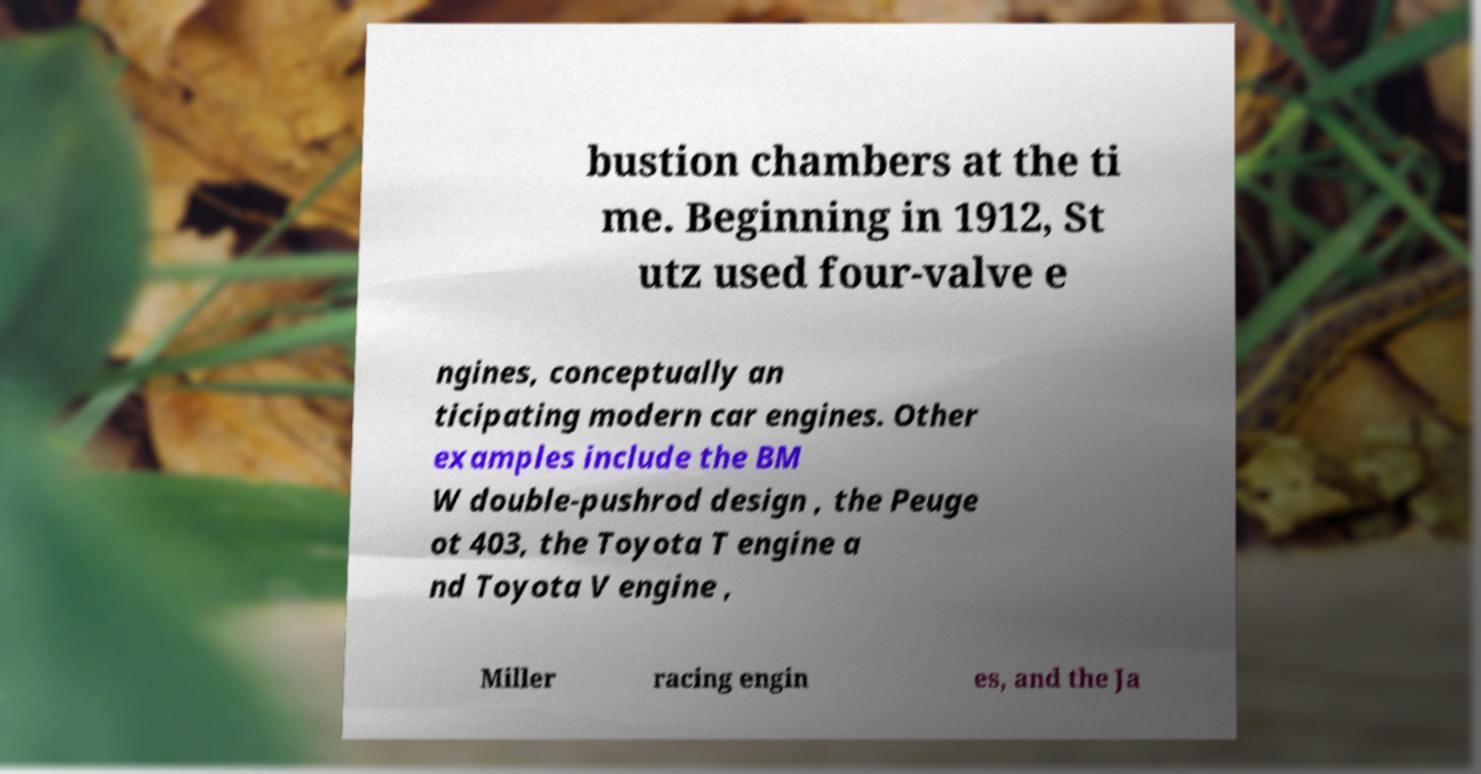Could you extract and type out the text from this image? bustion chambers at the ti me. Beginning in 1912, St utz used four-valve e ngines, conceptually an ticipating modern car engines. Other examples include the BM W double-pushrod design , the Peuge ot 403, the Toyota T engine a nd Toyota V engine , Miller racing engin es, and the Ja 